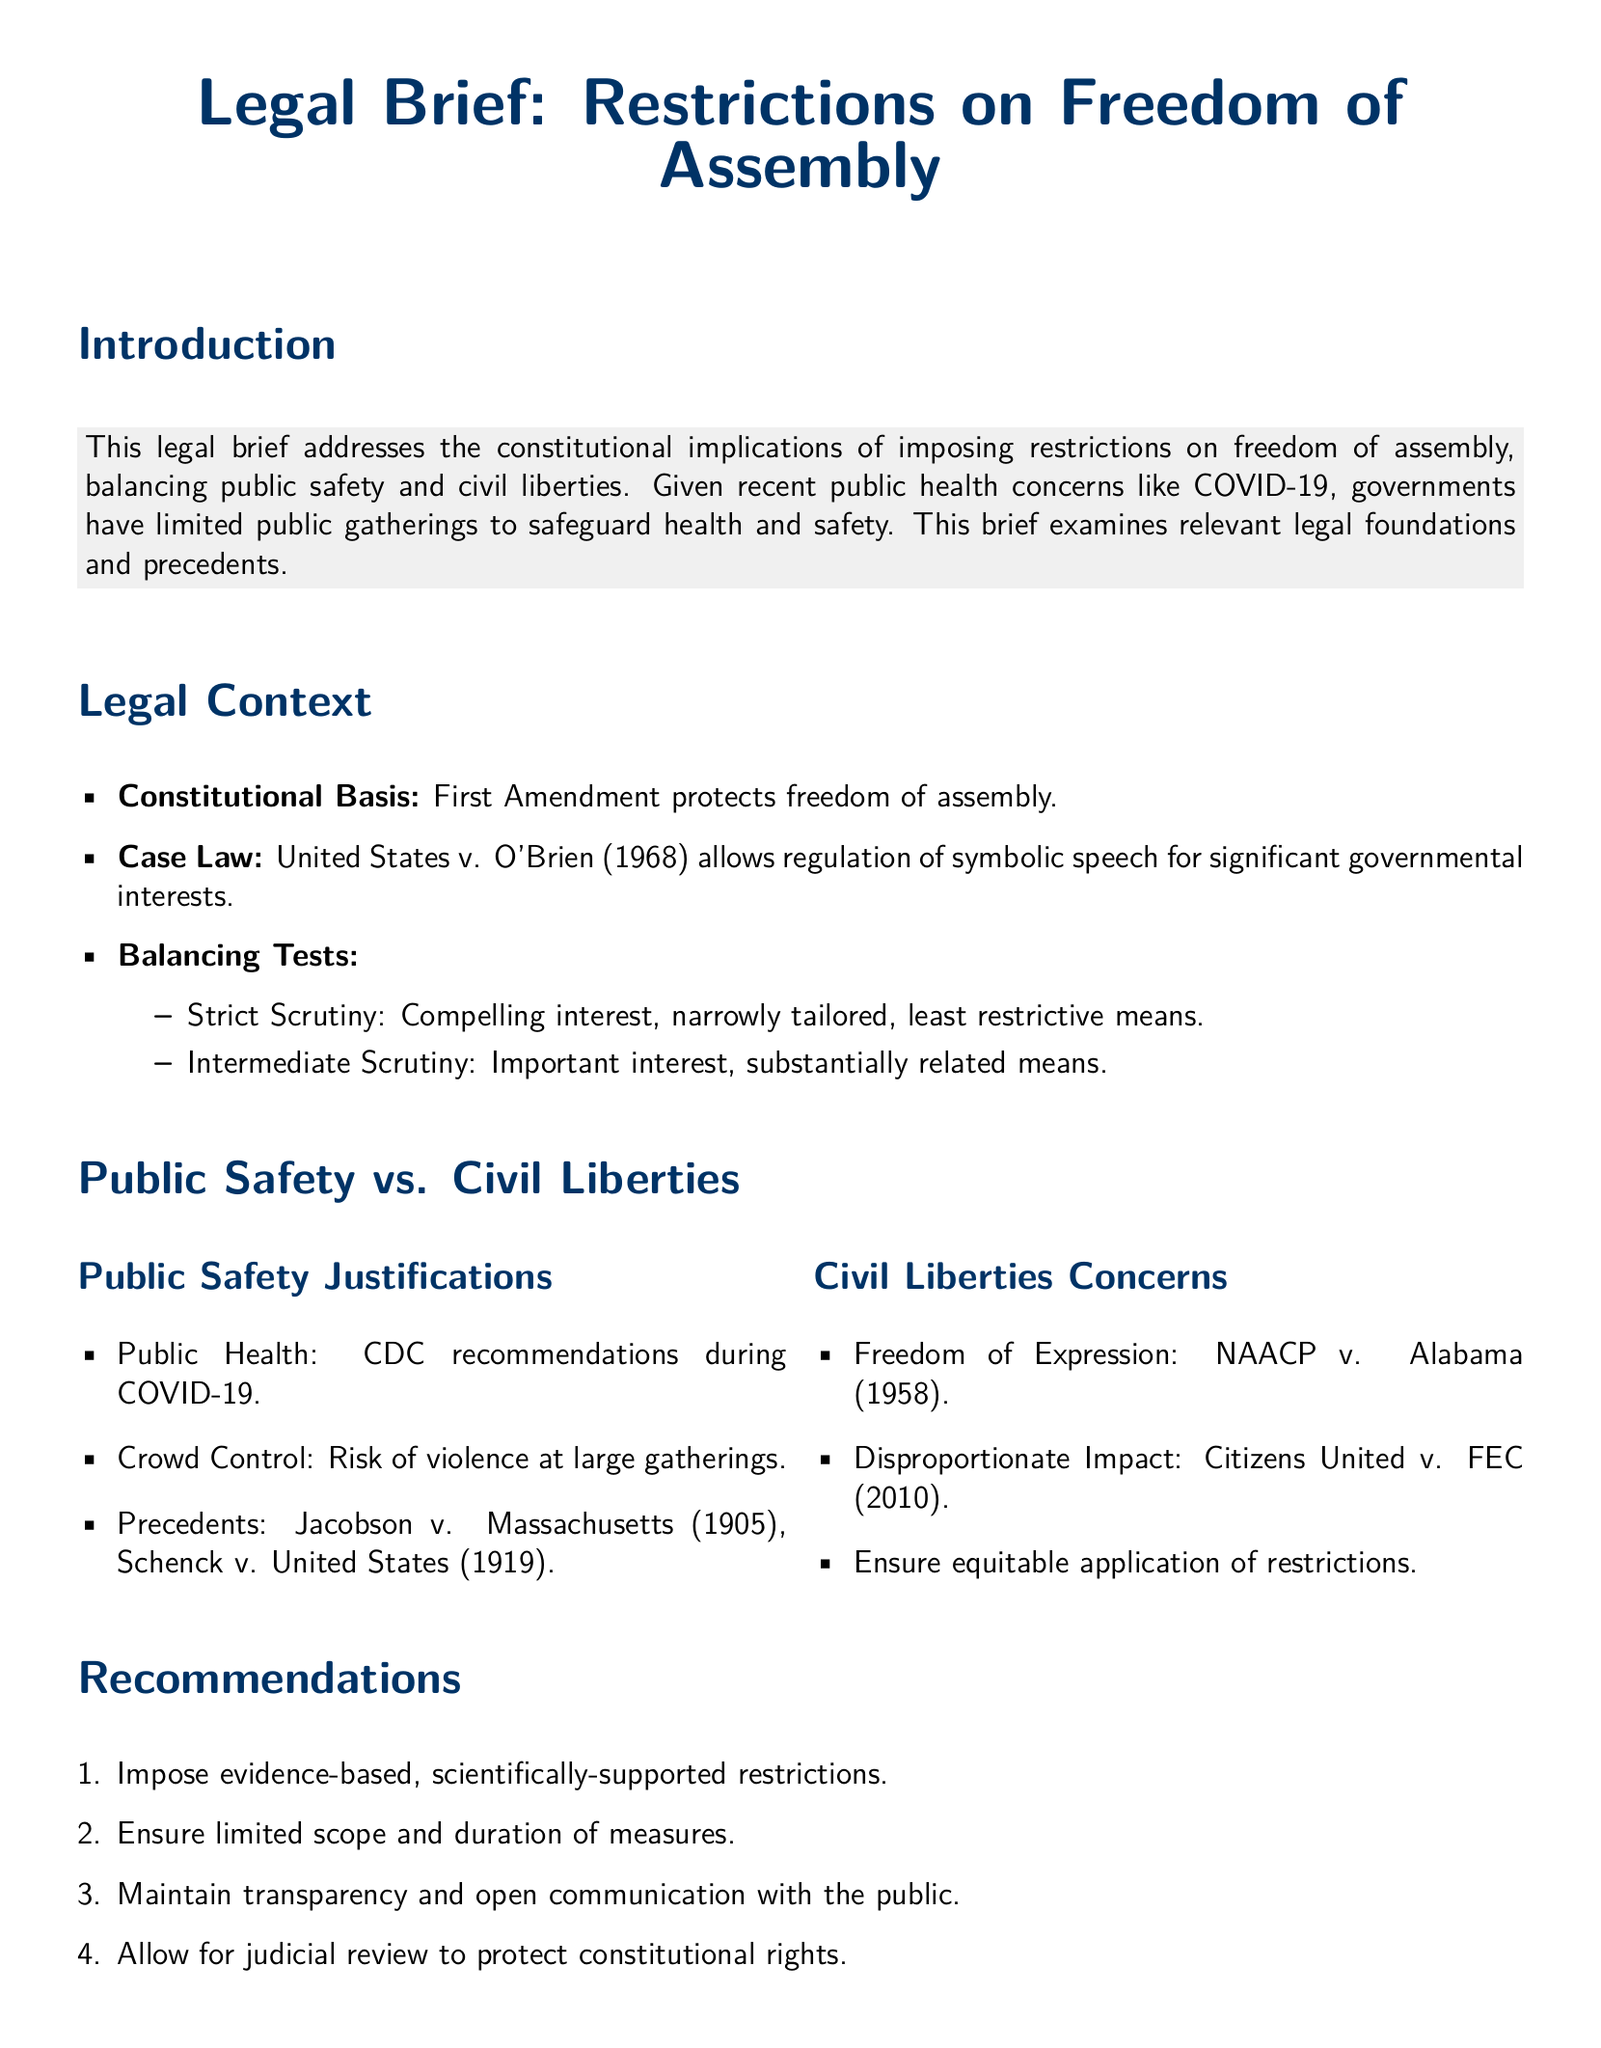What is the main topic of the legal brief? The main topic is about the constitutional implications of imposing restrictions on freedom of assembly.
Answer: Restrictions on Freedom of Assembly What amendment protects freedom of assembly? The First Amendment of the U.S. Constitution protects freedom of assembly.
Answer: First Amendment Which case established that government can regulate symbolic speech? The case that established this is United States v. O'Brien.
Answer: United States v. O'Brien What balancing test is used for compelling interest? The balancing test used is Strict Scrutiny.
Answer: Strict Scrutiny What public health concern is specifically mentioned? The public health concern specifically mentioned is COVID-19.
Answer: COVID-19 Which precedent case is referenced for public health justification? Jacobson v. Massachusetts (1905) is referenced.
Answer: Jacobson v. Massachusetts (1905) What is one recommended action for imposing restrictions? One recommended action is to impose evidence-based, scientifically-supported restrictions.
Answer: Evidence-based, scientifically-supported restrictions Which case is cited for freedom of expression concerns? The case cited is NAACP v. Alabama (1958).
Answer: NAACP v. Alabama (1958) What is emphasized in the conclusion of the legal brief? The conclusion emphasizes the balance between public safety needs and civil liberties.
Answer: Balance between public safety needs and civil liberties 